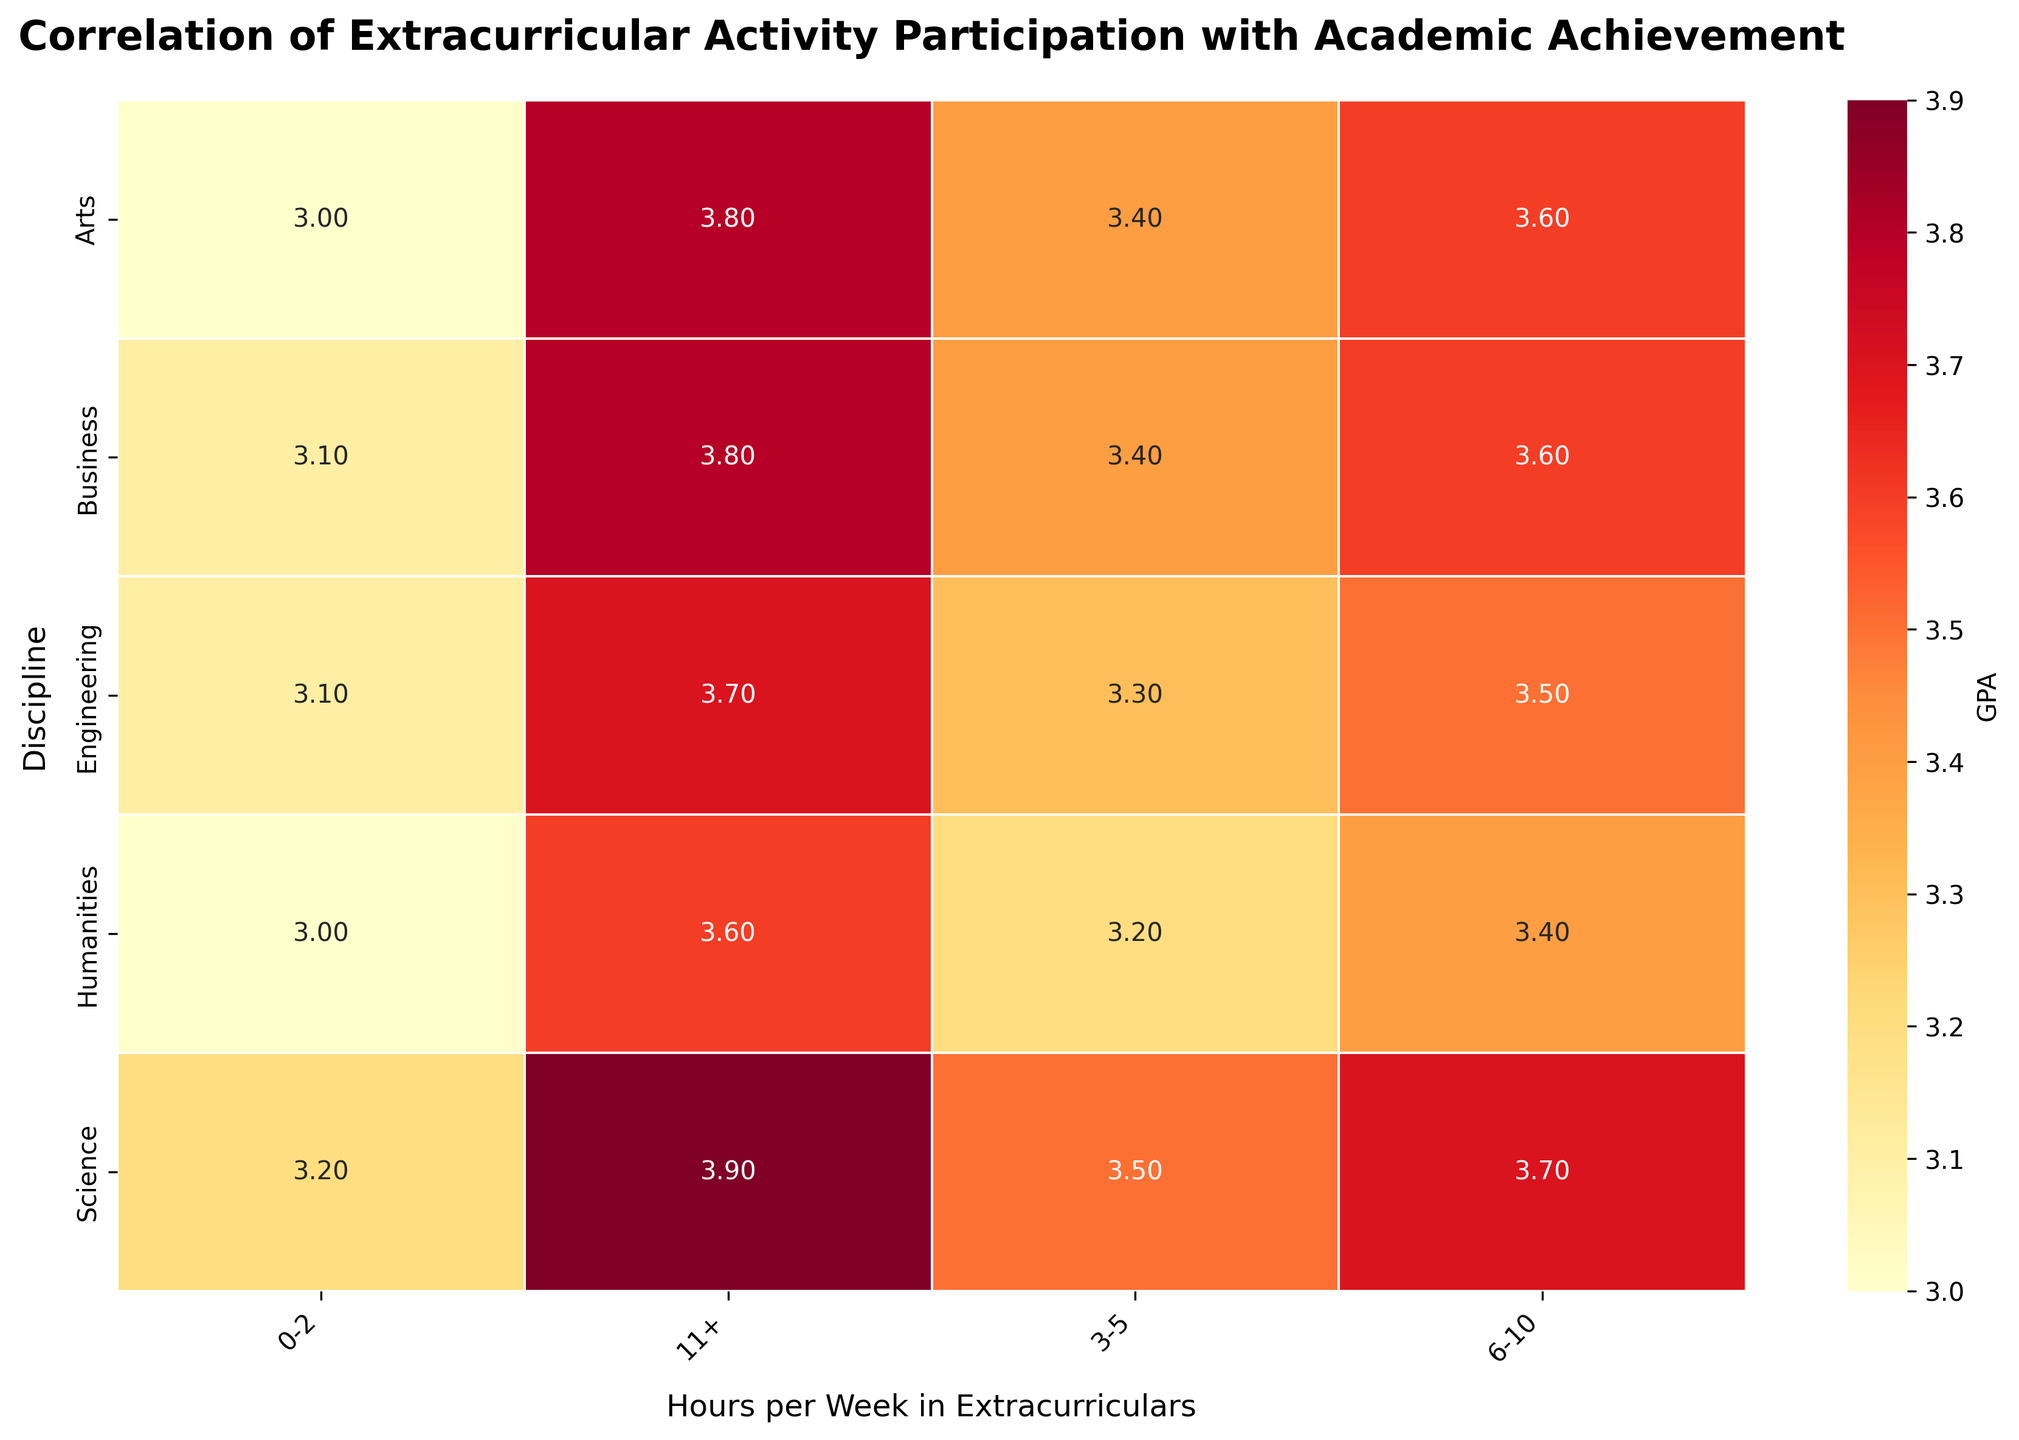What is the title of the heatmap? The title is located at the top of the heatmap and is usually in a larger and bold font compared to the other text.
Answer: Correlation of Extracurricular Activity Participation with Academic Achievement Which discipline has the highest GPA for 11+ hours per week in extracurriculars? Look for the column labeled '11+' and find the row with the maximum value under this column.
Answer: Science What is the average GPA for Engineering across all categories of hours per week in extracurriculars? Sum up the GPAs for Engineering and divide by the number of categories (0.2, 3.3, 3.5, 3.7), then divide by 4.
Answer: 3.4 Does participation in extracurricular activities seem to affect GPA differently across disciplines? Compare the trend in GPAs across different disciplines and see if the change in GPA with increasing hours of extracurricular activities follows the same pattern.
Answer: Yes Which two disciplines have the lowest starting GPA (0-2 hours) in extracurricular activities? Look at the column labeled '0-2' and identify the two disciplines with the lowest values.
Answer: Humanities and Arts How does the GPA for Business students change from 0-2 hours to 11+ hours of weekly extracurricular activities? Track the GPAs for Business in the '0-2' and '11+' columns and note the difference.
Answer: It increases from 3.1 to 3.8 Which discipline shows the smallest change in GPA as hours per week in extracurriculars increase? Identify the discipline with the smallest difference between its GPA at '0-2' hours and its GPA at '11+' hours.
Answer: Humanities Is there a discipline where students always have a higher GPA than those in Business across all hours per week categories? Compare the GPAs of each discipline with the Business discipline across all columns.
Answer: No In which category of hours per week in extracurriculars do Arts and Humanities students have the same GPA? Examine where the GPA values of Arts and Humanities students overlap across the columns.
Answer: 0-2 hours If a student from the Engineering discipline increases their participation in extracurricular activities from 3-5 hours to 6-10 hours per week, by how much would their GPA increase? Find the difference in GPAs between the '6-10' and '3-5' columns for the Engineering discipline.
Answer: 0.20 